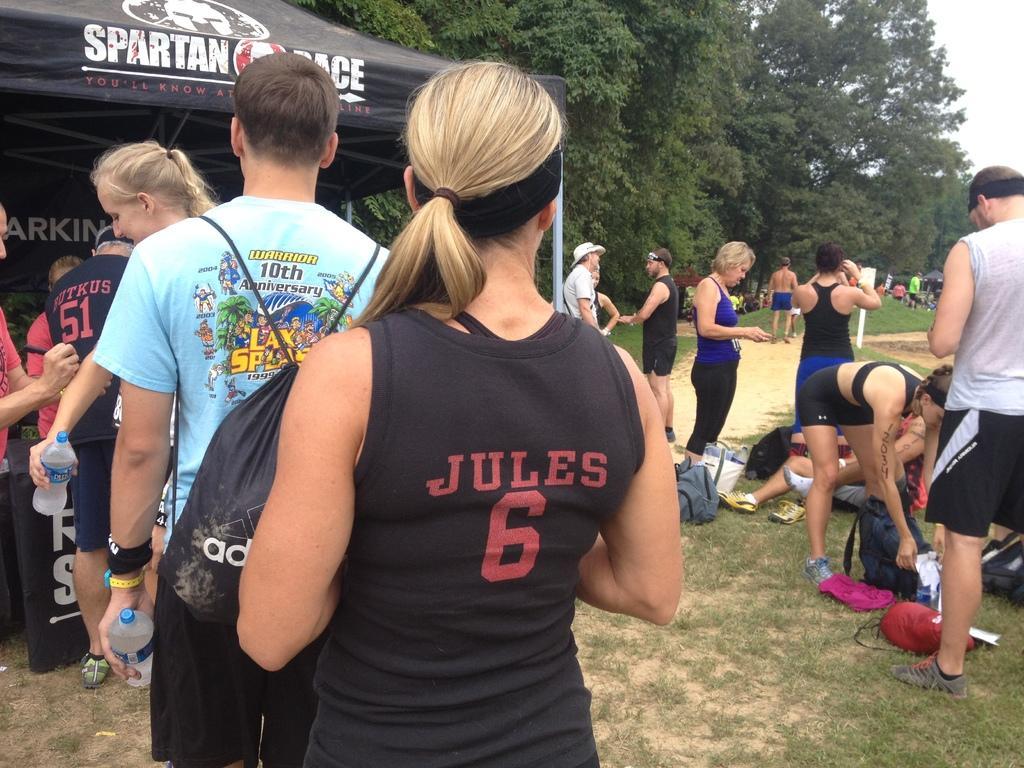How would you summarize this image in a sentence or two? In this picture there are few persons standing on the greenery ground and there is an black color object in front of them and there are few persons and trees in the right corner. 